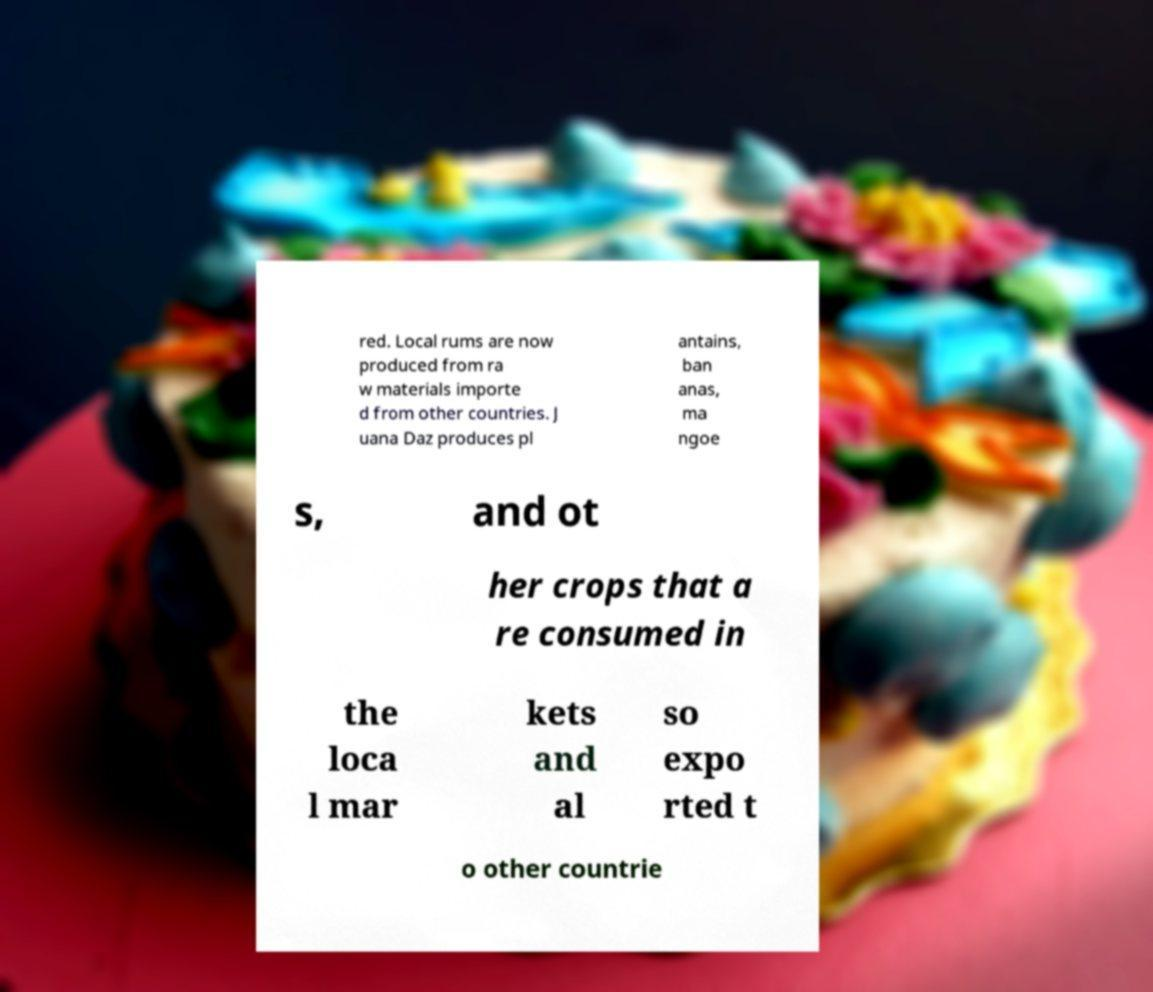Could you extract and type out the text from this image? red. Local rums are now produced from ra w materials importe d from other countries. J uana Daz produces pl antains, ban anas, ma ngoe s, and ot her crops that a re consumed in the loca l mar kets and al so expo rted t o other countrie 